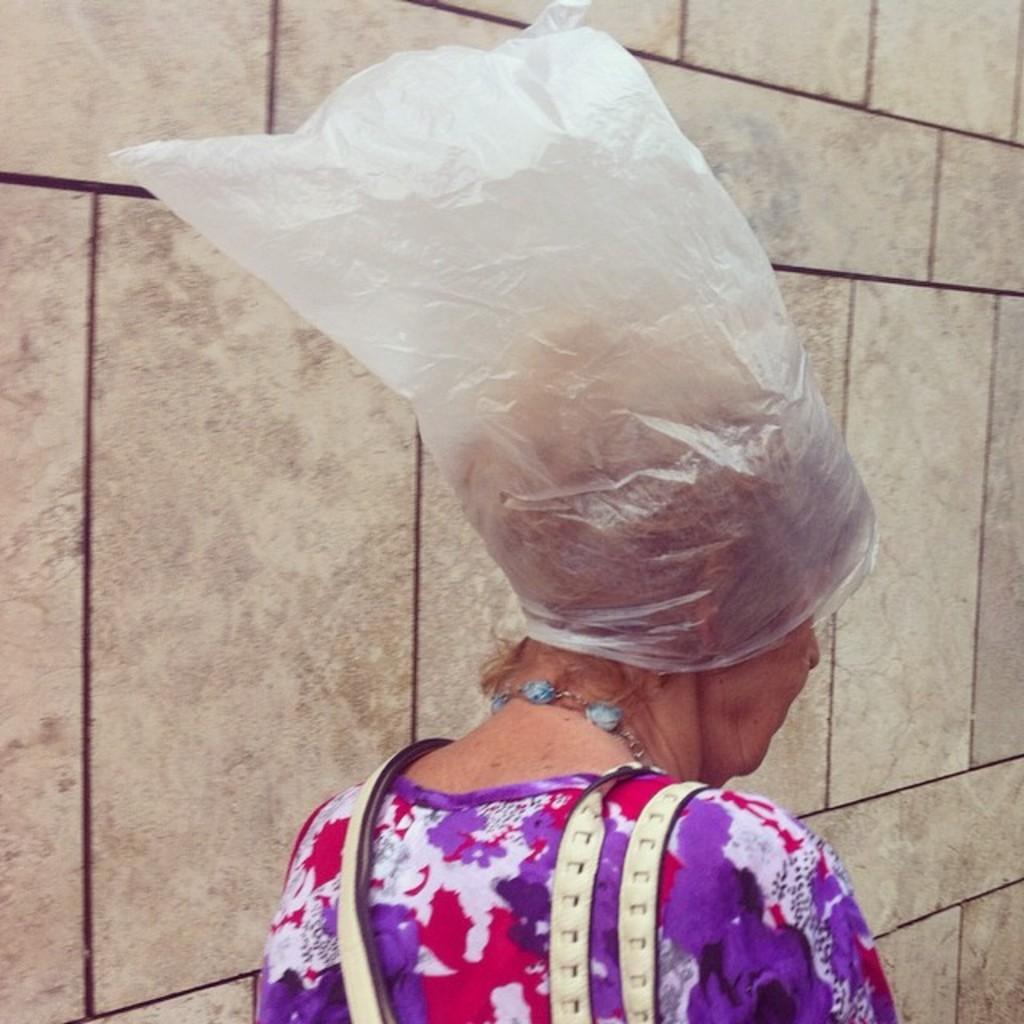Describe this image in one or two sentences. In this picture I can see a woman wearing a plastic cover on her head, in the background there is the wall. 